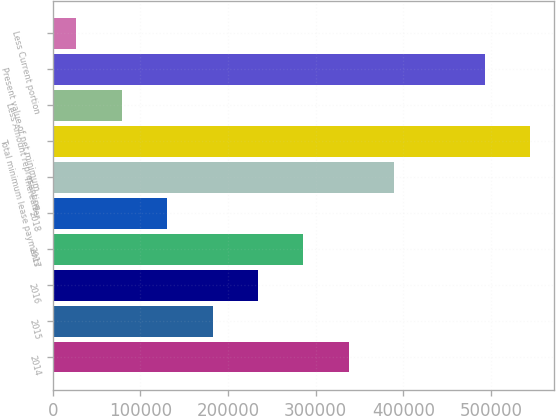<chart> <loc_0><loc_0><loc_500><loc_500><bar_chart><fcel>2014<fcel>2015<fcel>2016<fcel>2017<fcel>2018<fcel>Thereafter<fcel>Total minimum lease payments<fcel>Less Amount representing<fcel>Present value of net minimum<fcel>Less Current portion<nl><fcel>337512<fcel>182277<fcel>234022<fcel>285767<fcel>130532<fcel>389257<fcel>544492<fcel>78787<fcel>492747<fcel>27042<nl></chart> 